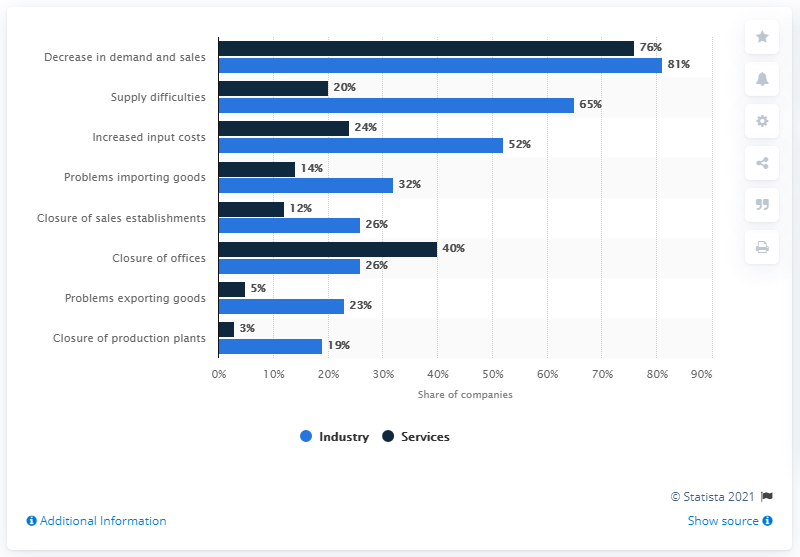Point out several critical features in this image. During the COVID-19 pandemic, 81% of industrial companies experienced a decline in sales. What is the value of the shortest navy blue bar? It is 3. The second greatest difference between industry and services is due to increased input costs. 